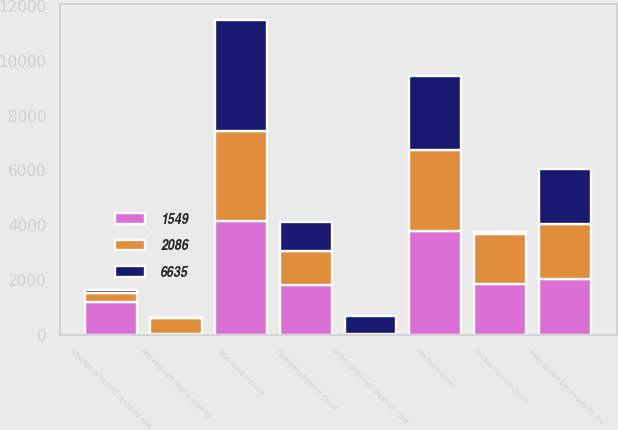Convert chart. <chart><loc_0><loc_0><loc_500><loc_500><stacked_bar_chart><ecel><fcel>Years Ended December 31 (in<fcel>Pre-tax income (loss)<fcel>Net realized capital (gains)<fcel>Other (income) expense - net<fcel>Operating income (loss)<fcel>Pre-tax income<fcel>Change in benefit reserves and<fcel>Operating income<nl><fcel>1549<fcel>2012<fcel>1837<fcel>2<fcel>2<fcel>1820<fcel>3780<fcel>1201<fcel>4160<nl><fcel>2086<fcel>2011<fcel>1820<fcel>607<fcel>5<fcel>1218<fcel>2956<fcel>327<fcel>3277<nl><fcel>6635<fcel>2010<fcel>93<fcel>38<fcel>669<fcel>1056<fcel>2701<fcel>104<fcel>4056<nl></chart> 